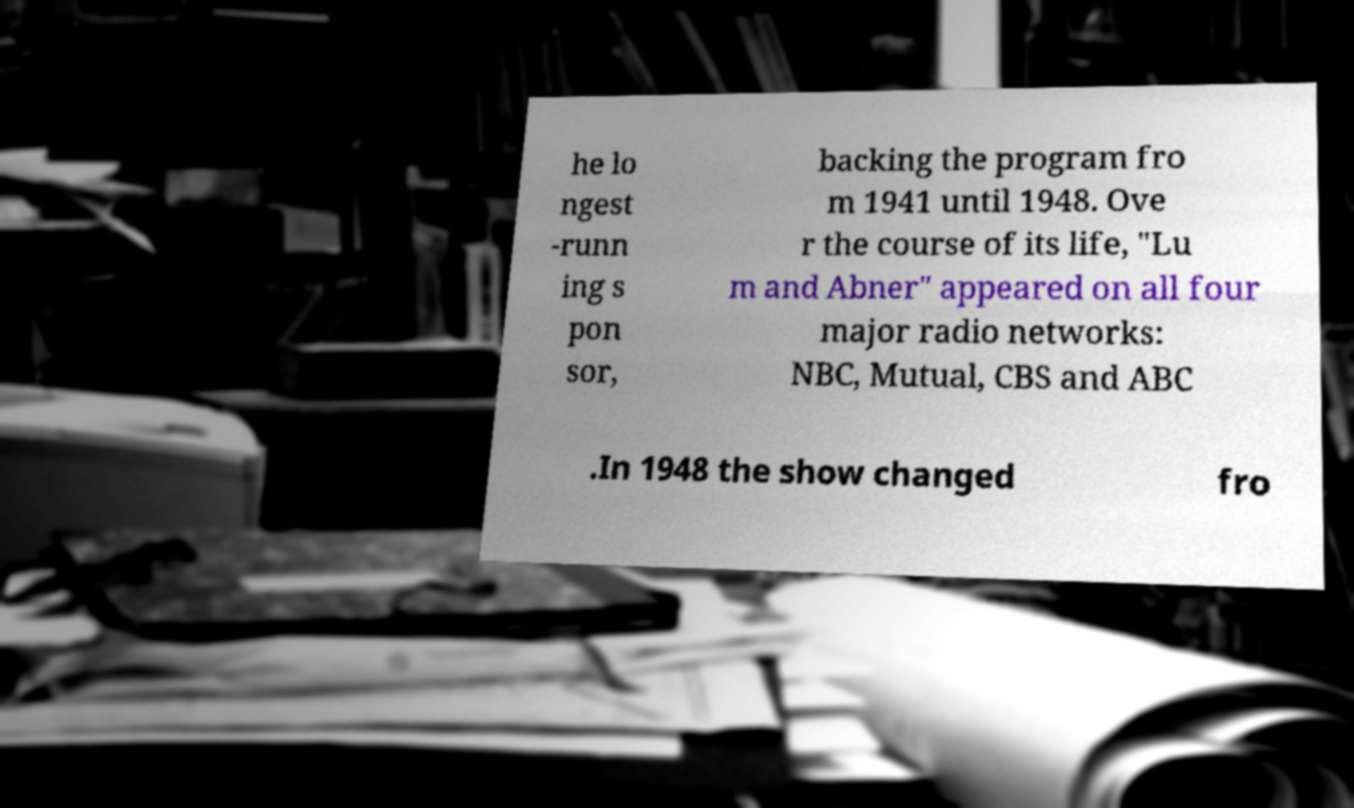Can you accurately transcribe the text from the provided image for me? he lo ngest -runn ing s pon sor, backing the program fro m 1941 until 1948. Ove r the course of its life, "Lu m and Abner" appeared on all four major radio networks: NBC, Mutual, CBS and ABC .In 1948 the show changed fro 